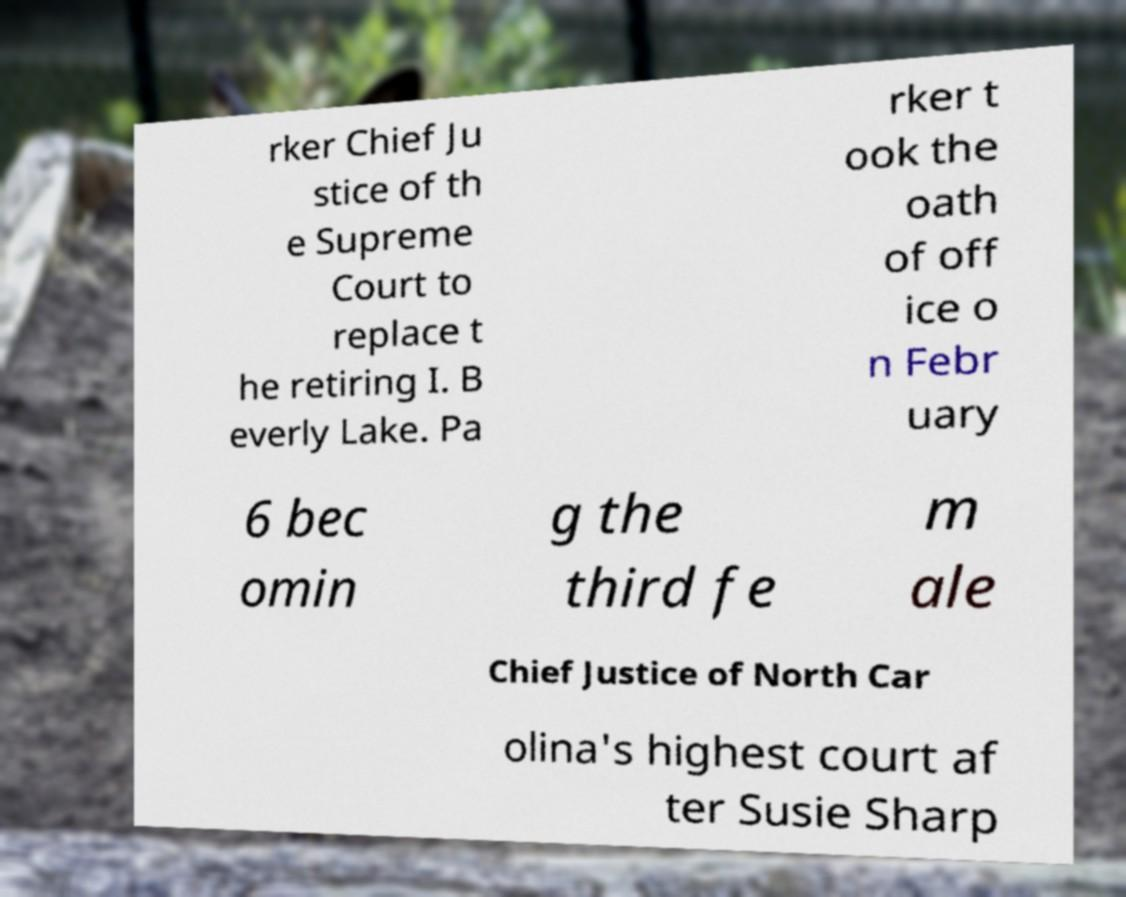Can you accurately transcribe the text from the provided image for me? rker Chief Ju stice of th e Supreme Court to replace t he retiring I. B everly Lake. Pa rker t ook the oath of off ice o n Febr uary 6 bec omin g the third fe m ale Chief Justice of North Car olina's highest court af ter Susie Sharp 